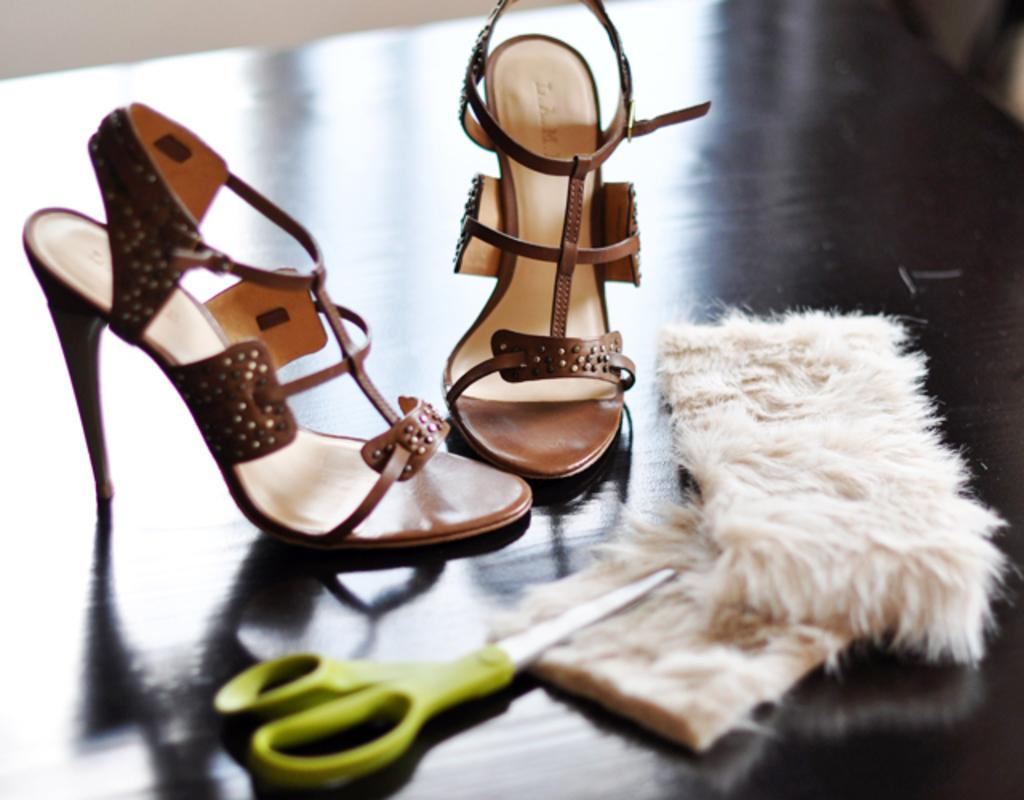What type of footwear is visible in the image? There are sandals in the image. What tool is present in the image? There are scissors in the image. What kind of surface can be seen in the image? There is a solid surface in the image. What type of lace can be seen on the bird in the image? There is no bird present in the image, and therefore no lace can be seen on it. 